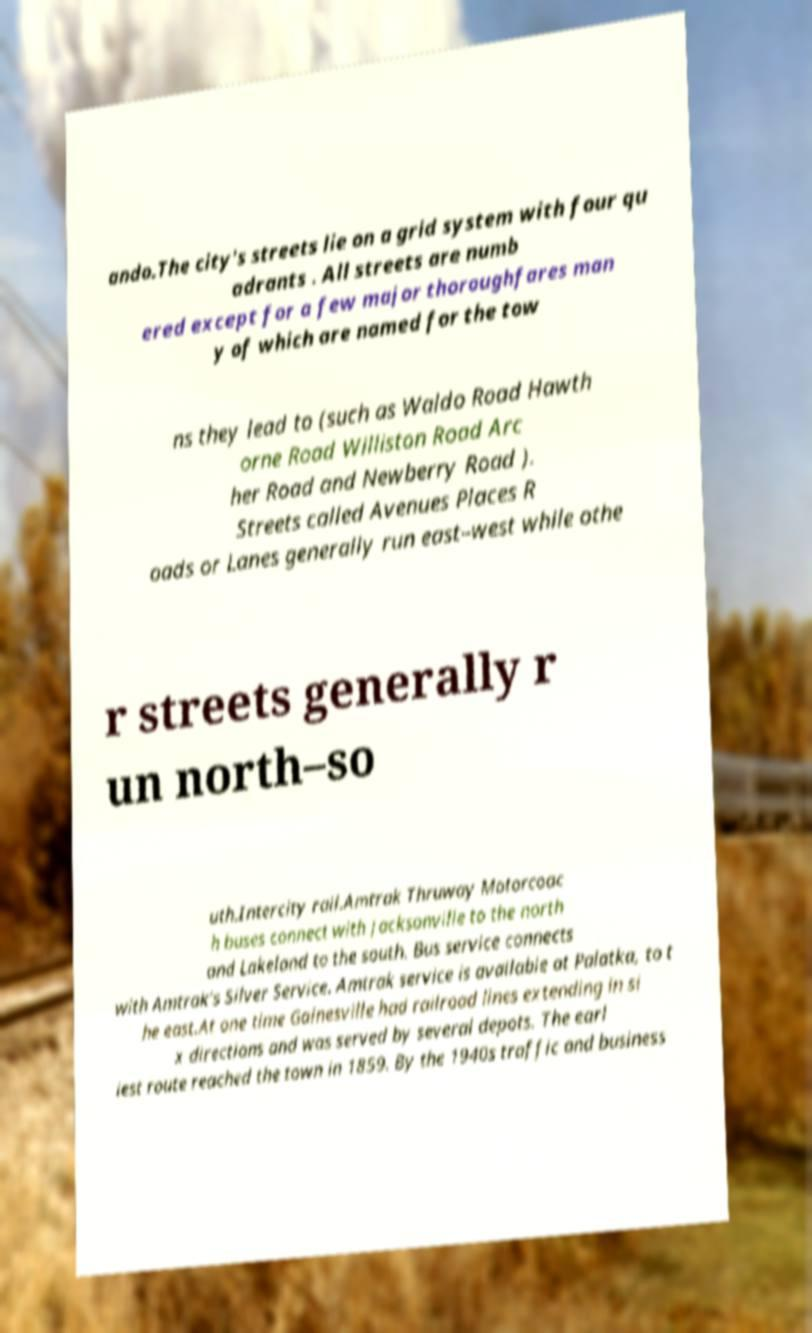There's text embedded in this image that I need extracted. Can you transcribe it verbatim? ando.The city's streets lie on a grid system with four qu adrants . All streets are numb ered except for a few major thoroughfares man y of which are named for the tow ns they lead to (such as Waldo Road Hawth orne Road Williston Road Arc her Road and Newberry Road ). Streets called Avenues Places R oads or Lanes generally run east–west while othe r streets generally r un north–so uth.Intercity rail.Amtrak Thruway Motorcoac h buses connect with Jacksonville to the north and Lakeland to the south. Bus service connects with Amtrak's Silver Service. Amtrak service is available at Palatka, to t he east.At one time Gainesville had railroad lines extending in si x directions and was served by several depots. The earl iest route reached the town in 1859. By the 1940s traffic and business 